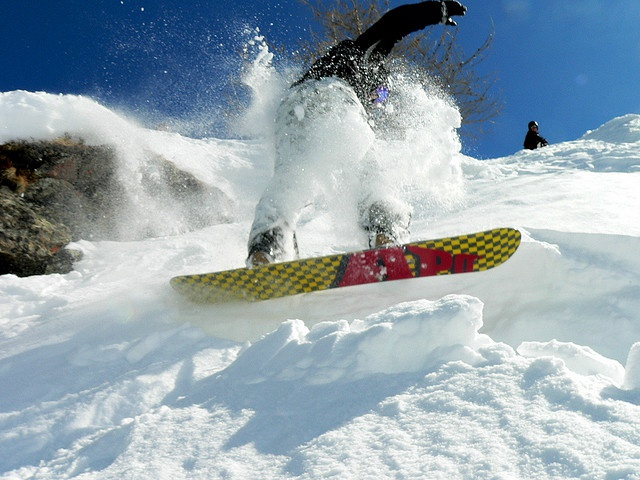Describe the objects in this image and their specific colors. I can see people in navy, lightgray, darkgray, black, and gray tones, snowboard in navy, maroon, olive, and gray tones, and people in navy, black, gray, and maroon tones in this image. 